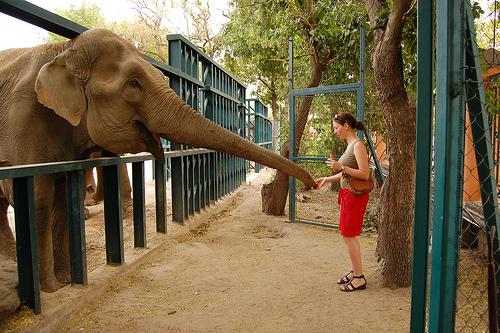Question: why is the elephant's trunk outstretched?
Choices:
A. To attack.
B. To take food.
C. To stretch it out.
D. To warn other elephants.
Answer with the letter. Answer: B Question: where is this scene?
Choices:
A. In a giraffe exhibit.
B. At a museum.
C. At the zoo.
D. At a library.
Answer with the letter. Answer: C Question: what animal is pictured?
Choices:
A. Zebra.
B. Rhino.
C. Bear.
D. An elephant.
Answer with the letter. Answer: D Question: how many women are pictured?
Choices:
A. Two.
B. Four.
C. One.
D. Six.
Answer with the letter. Answer: C Question: what is the woman doing?
Choices:
A. Laughing at the elephant.
B. Singing to the elephant.
C. Riding the elephant.
D. Feeding the elephant.
Answer with the letter. Answer: D 